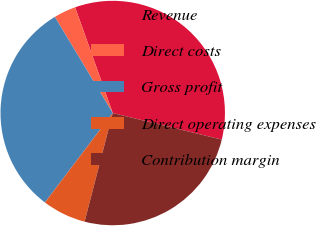Convert chart to OTSL. <chart><loc_0><loc_0><loc_500><loc_500><pie_chart><fcel>Revenue<fcel>Direct costs<fcel>Gross profit<fcel>Direct operating expenses<fcel>Contribution margin<nl><fcel>34.24%<fcel>3.19%<fcel>31.05%<fcel>6.29%<fcel>25.23%<nl></chart> 